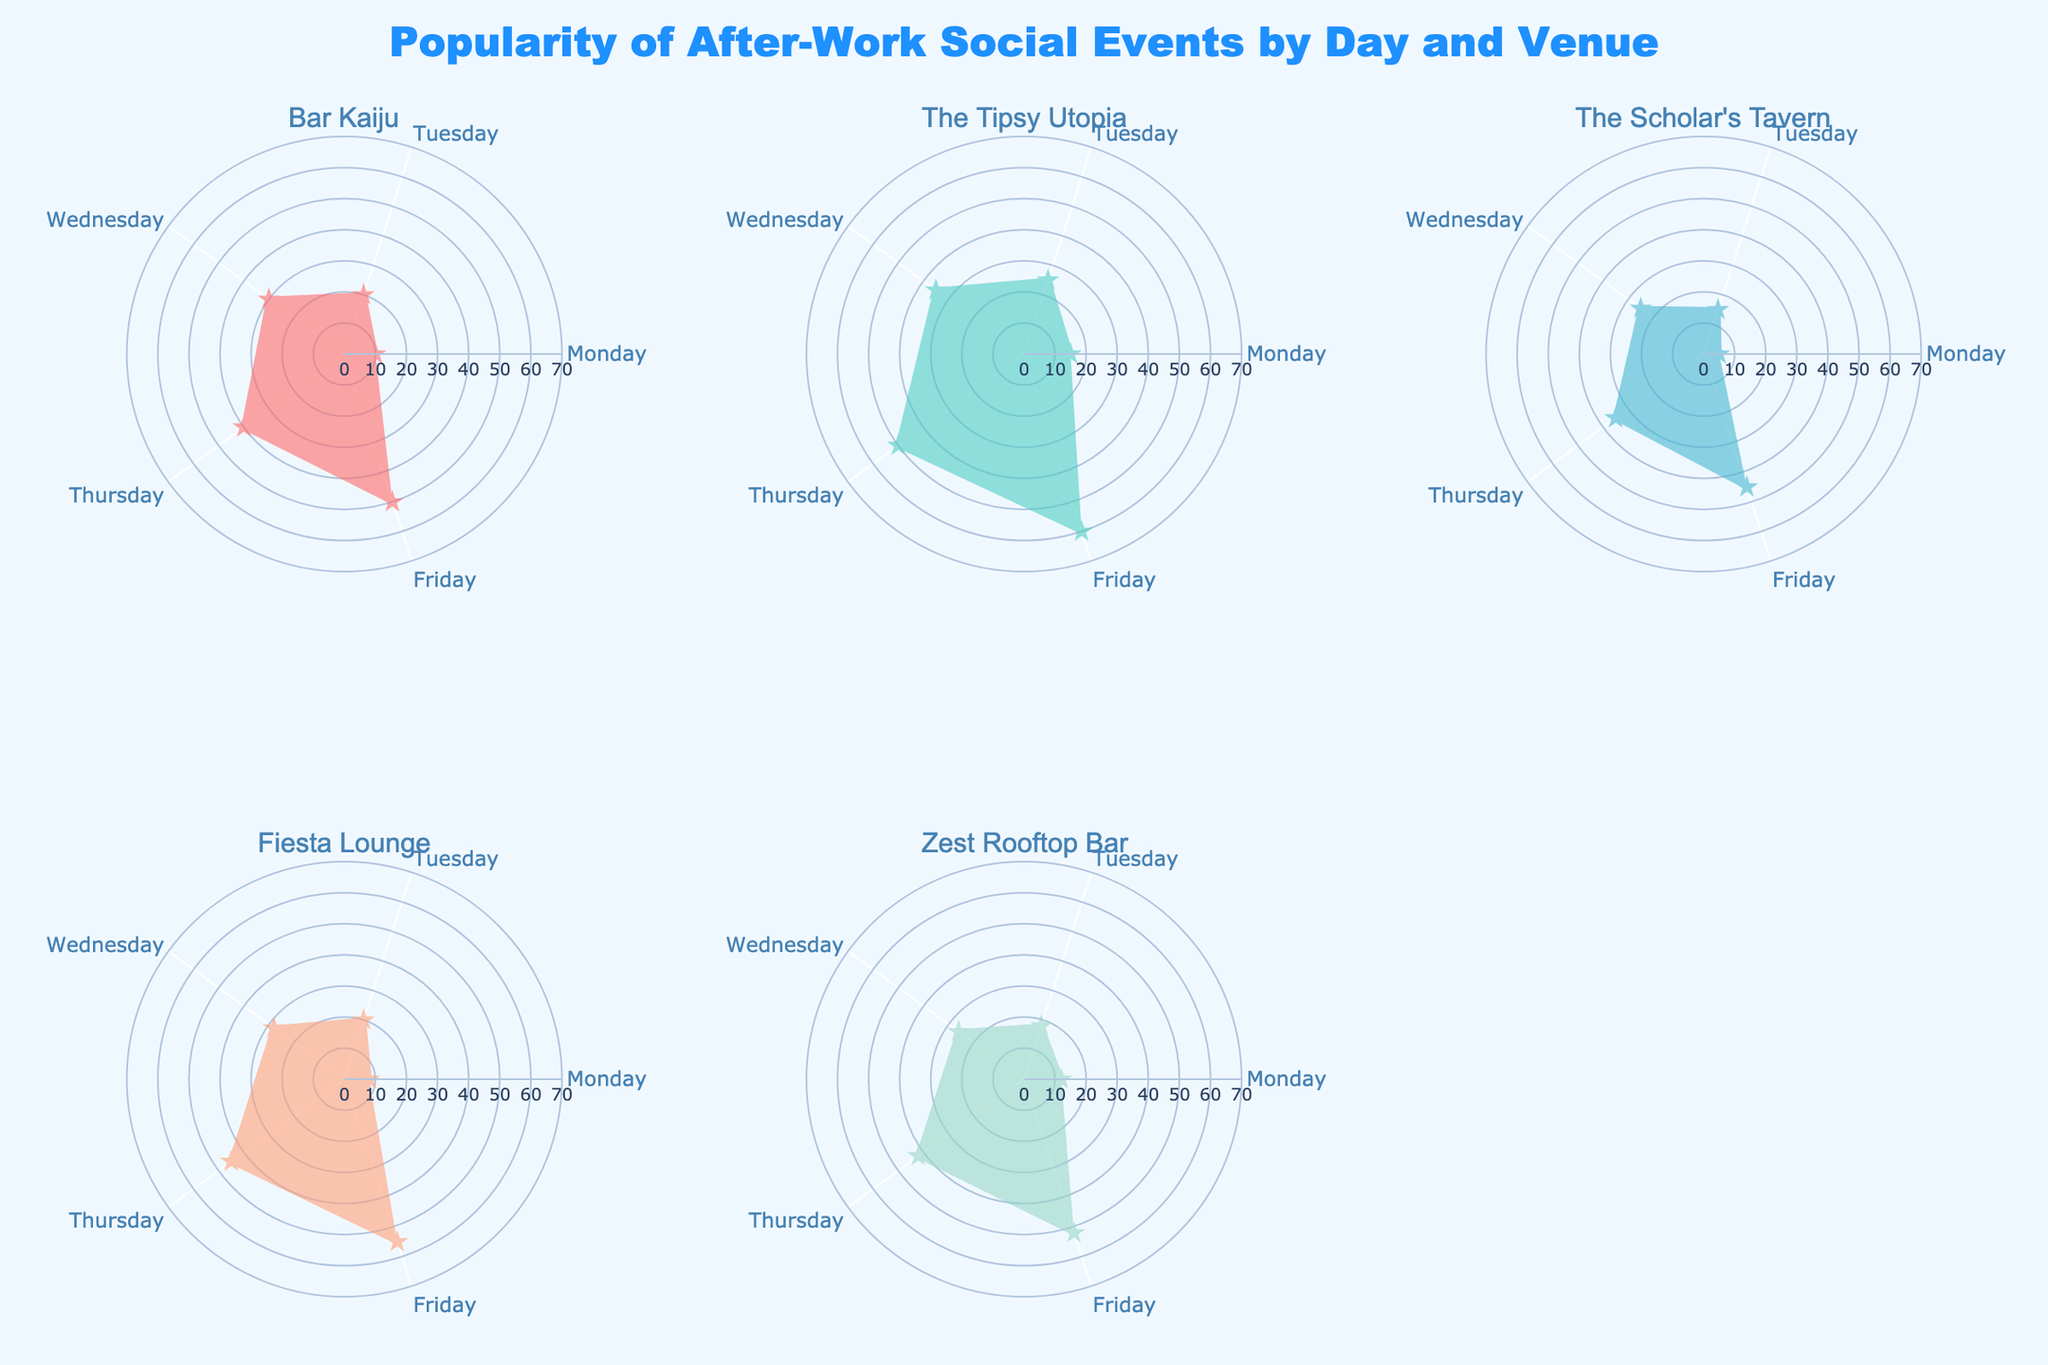What's the title of the figure? The title is shown at the top center of the figure, which provides a clear summary of what the chart is about.
Answer: Popularity of After-Work Social Events by Day and Venue How many days of the week are represented in the chart? Each subplot represents data points for various days of the week, and by counting the labels on the theta axis, we can verify their number.
Answer: 5 Which venue has the highest popularity on Thursday? By looking at the subplots for each venue and checking the point on Thursday's radial axis for the maximum value, we can identify the highest value.
Answer: The Tipsy Utopia What is the overall trend in popularity from Monday to Friday for Bar Kaiju? By observing the radial distances for Bar Kaiju from Monday through Friday, we can see the pattern of changes over the week.
Answer: Increasing Which day of the week has the lowest popularity for The Scholar's Tavern? Check the values on the radial axis of The Scholar's Tavern subplot and identify the day with the smallest value.
Answer: Monday Compare the popularity of Fiesta Lounge on Tuesday vs Friday. Observe the radial distances for Fiesta Lounge on Tuesday and Friday and note which is higher.
Answer: Friday What's the difference in popularity for Zest Rooftop Bar between Wednesday and Friday? Subtract the value on Wednesday's radial axis from the value on Friday's radial axis for the Zest Rooftop Bar subplot.
Answer: 26 Which venue experienced the largest increase in popularity from Monday to Friday? Calculate the difference for each venue from Monday to Friday and determine which has the largest increase.
Answer: The Tipsy Utopia Which venue is least popular on Monday? Check and compare the values for each venue on Monday's radial axis to find the smallest one.
Answer: The Scholar's Tavern 